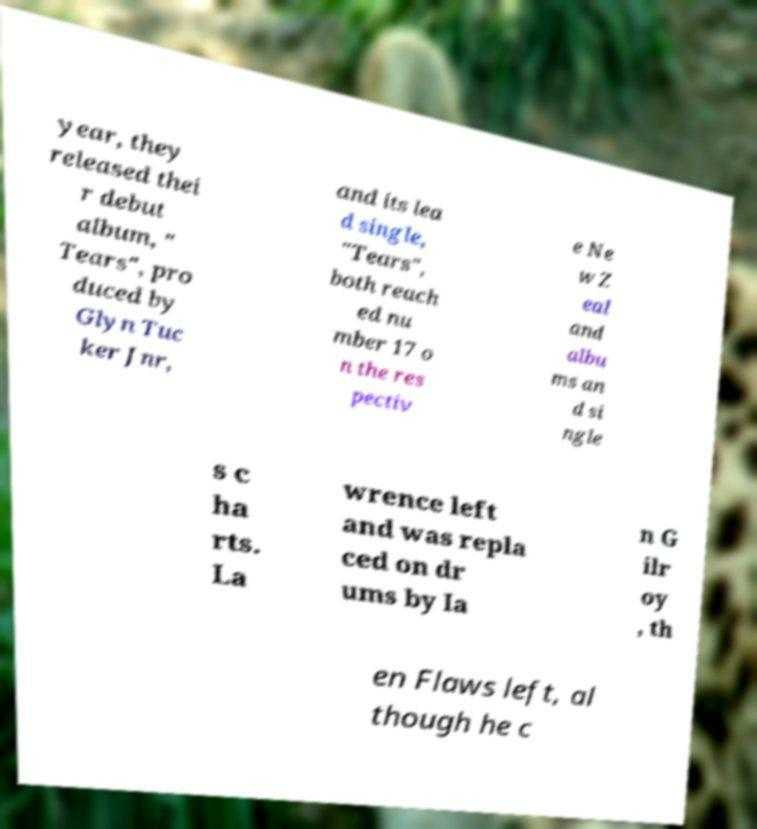Could you assist in decoding the text presented in this image and type it out clearly? year, they released thei r debut album, " Tears", pro duced by Glyn Tuc ker Jnr, and its lea d single, "Tears", both reach ed nu mber 17 o n the res pectiv e Ne w Z eal and albu ms an d si ngle s c ha rts. La wrence left and was repla ced on dr ums by Ia n G ilr oy , th en Flaws left, al though he c 